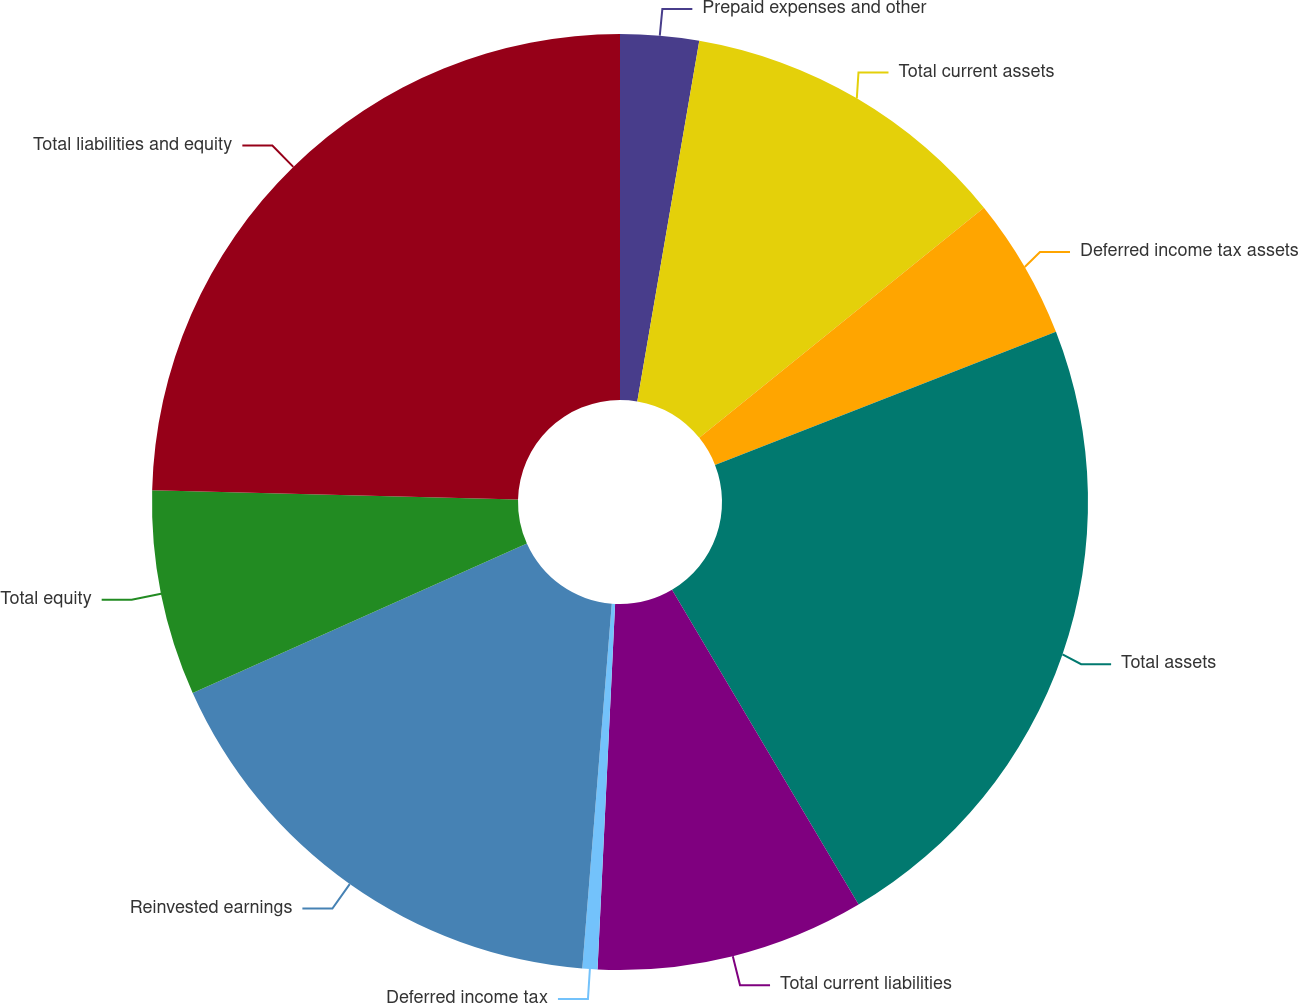<chart> <loc_0><loc_0><loc_500><loc_500><pie_chart><fcel>Prepaid expenses and other<fcel>Total current assets<fcel>Deferred income tax assets<fcel>Total assets<fcel>Total current liabilities<fcel>Deferred income tax<fcel>Reinvested earnings<fcel>Total equity<fcel>Total liabilities and equity<nl><fcel>2.71%<fcel>11.47%<fcel>4.9%<fcel>22.41%<fcel>9.28%<fcel>0.52%<fcel>17.03%<fcel>7.09%<fcel>24.6%<nl></chart> 